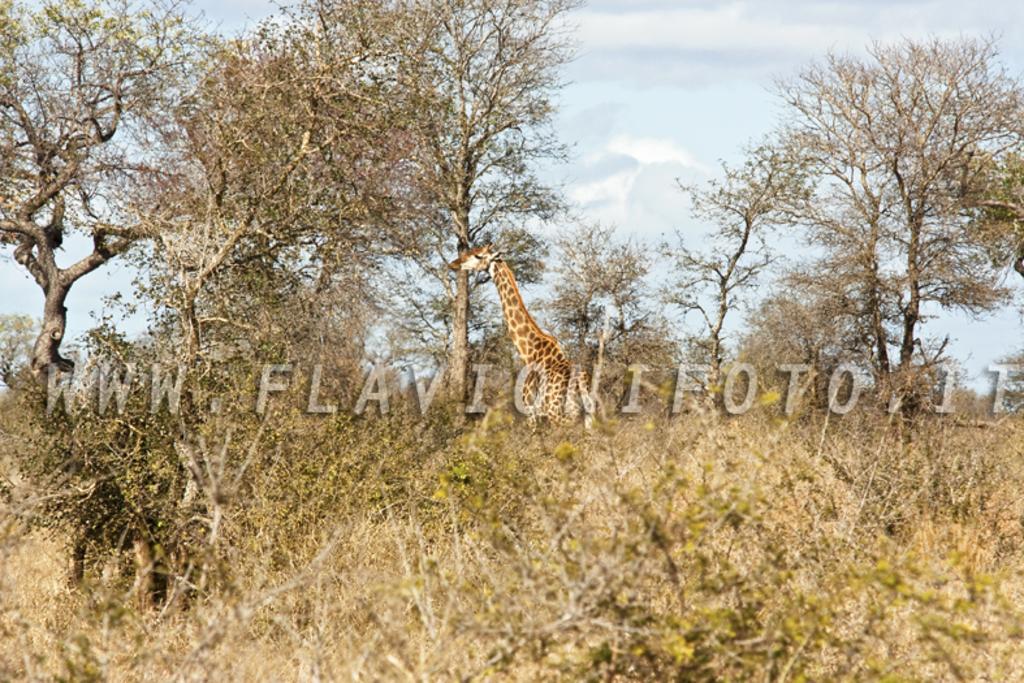Can you describe this image briefly? In this picture I can see a giraffe in the middle of the image. I can see the trees on the left side and the right side as well. I can see the clouds in the sky. 